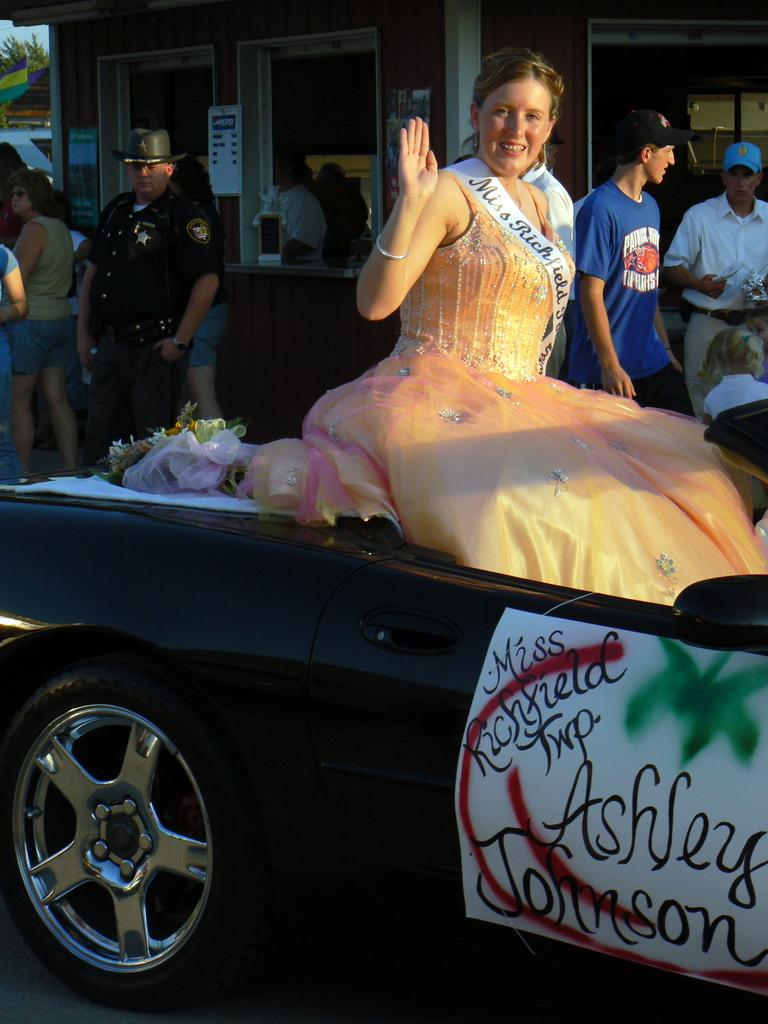What is the woman in the image doing? The woman is sitting on a car in the image. How is the car she is sitting on decorated? The car is decorated. What can be seen in the background of the image? There are people standing and walking, as well as buildings visible in the background of the image. How many lizards are crawling on the woman's leg in the image? There are no lizards present in the image. What things are the people in the background of the image holding? The facts provided do not mention any specific things that the people in the background are holding. 